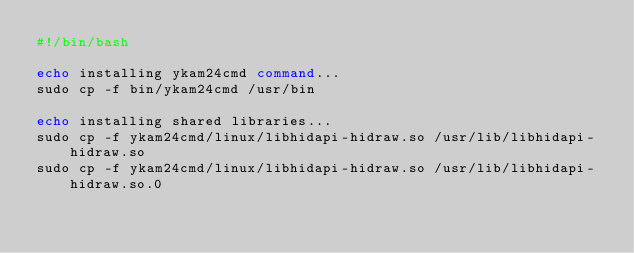<code> <loc_0><loc_0><loc_500><loc_500><_Bash_>#!/bin/bash

echo installing ykam24cmd command...
sudo cp -f bin/ykam24cmd /usr/bin

echo installing shared libraries...
sudo cp -f ykam24cmd/linux/libhidapi-hidraw.so /usr/lib/libhidapi-hidraw.so
sudo cp -f ykam24cmd/linux/libhidapi-hidraw.so /usr/lib/libhidapi-hidraw.so.0
</code> 